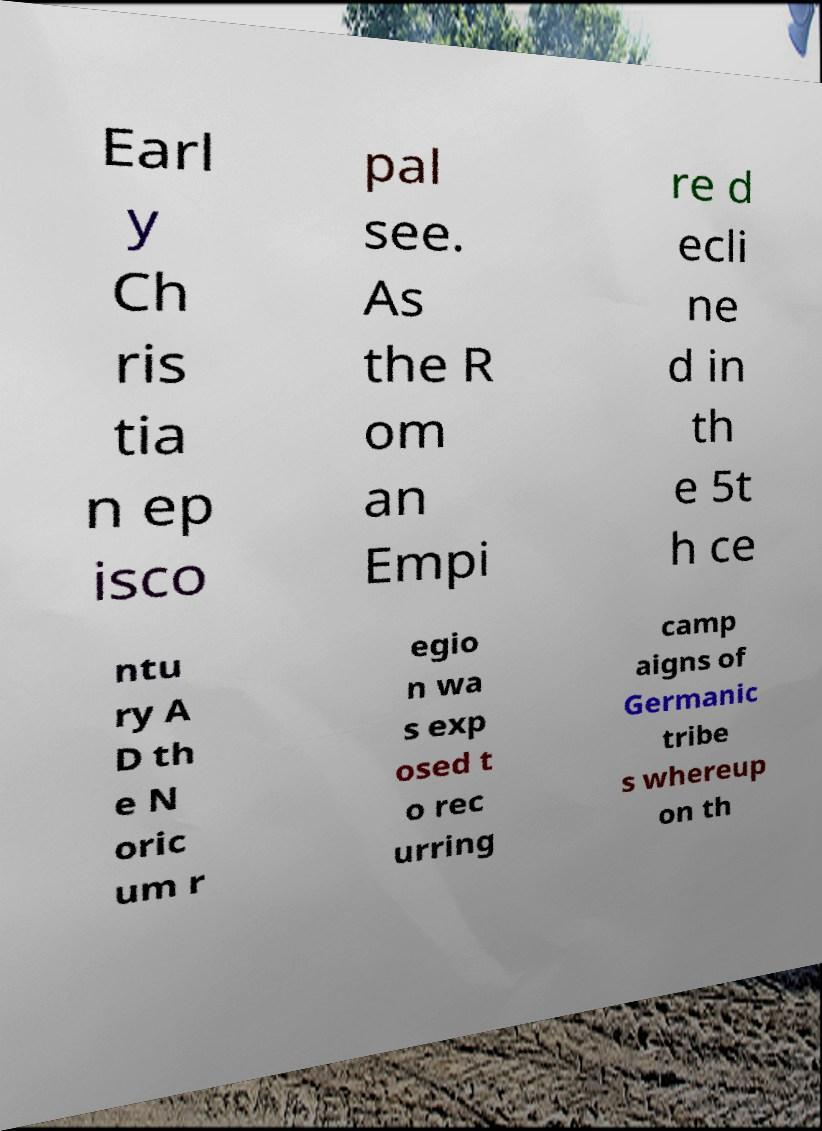Please read and relay the text visible in this image. What does it say? Earl y Ch ris tia n ep isco pal see. As the R om an Empi re d ecli ne d in th e 5t h ce ntu ry A D th e N oric um r egio n wa s exp osed t o rec urring camp aigns of Germanic tribe s whereup on th 